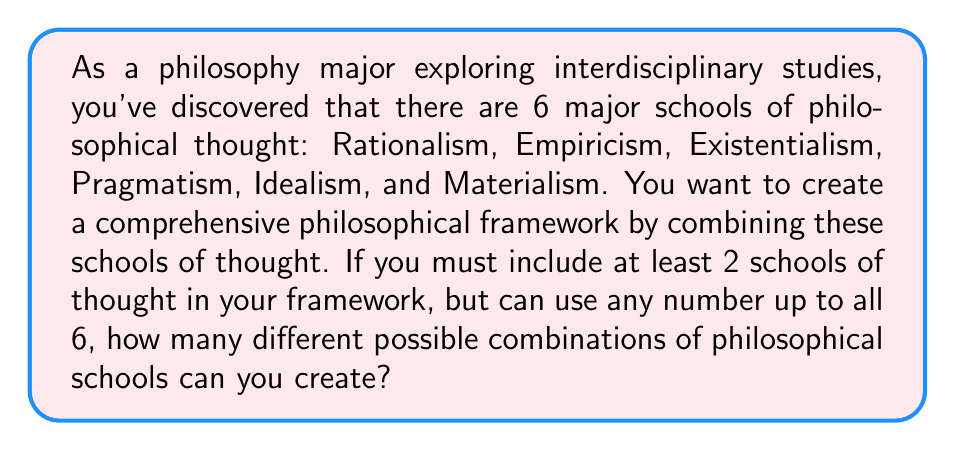Can you answer this question? Let's approach this step-by-step:

1) We need to find the sum of all possible combinations of 2, 3, 4, 5, and 6 schools of thought out of the 6 available.

2) This can be represented using the combination formula:

   $${6 \choose 2} + {6 \choose 3} + {6 \choose 4} + {6 \choose 5} + {6 \choose 6}$$

3) Let's calculate each term:

   ${6 \choose 2} = \frac{6!}{2!(6-2)!} = \frac{6 \cdot 5}{2 \cdot 1} = 15$

   ${6 \choose 3} = \frac{6!}{3!(6-3)!} = \frac{6 \cdot 5 \cdot 4}{3 \cdot 2 \cdot 1} = 20$

   ${6 \choose 4} = \frac{6!}{4!(6-4)!} = \frac{6 \cdot 5}{2 \cdot 1} = 15$

   ${6 \choose 5} = \frac{6!}{5!(6-5)!} = 6$

   ${6 \choose 6} = \frac{6!}{6!(6-6)!} = 1$

4) Now, we sum all these values:

   $15 + 20 + 15 + 6 + 1 = 57$

Therefore, there are 57 different possible combinations of philosophical schools that can be created.
Answer: 57 possible combinations 